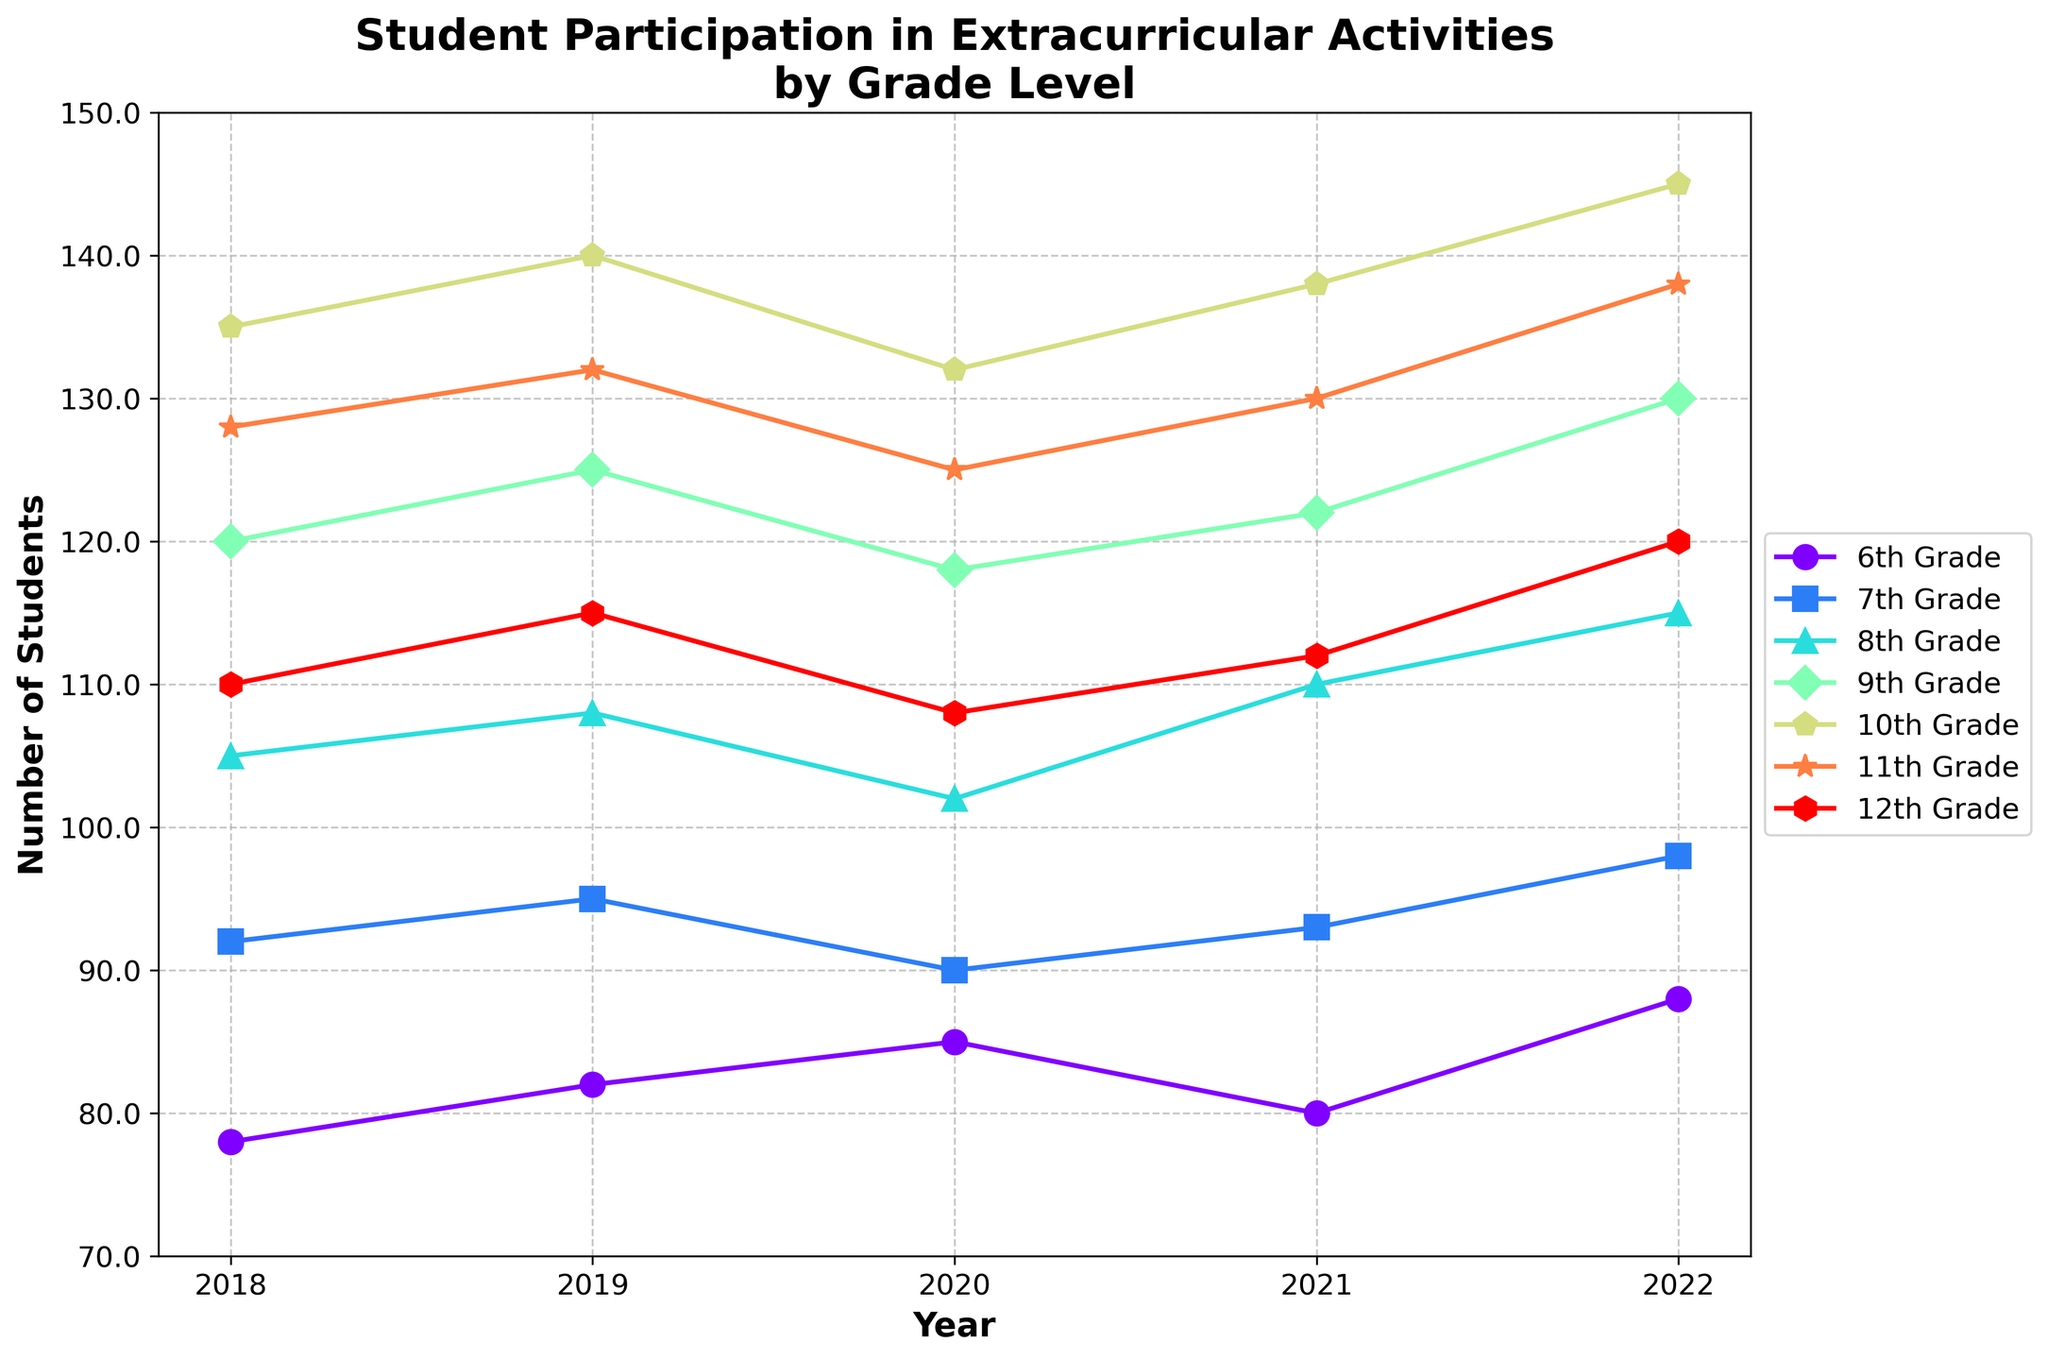What grade level saw the highest number of students participating in extracurricular activities in 2022? To find out which grade level had the highest number of students participating in 2022, look at the highest point on the y-axis corresponding to the year 2022 for all lines. The line for the 10th Grade reaches the highest value.
Answer: 10th Grade Which grade level had the lowest participation in 2018? Check the y-axis values for all grade levels in the year 2018. The 6th Grade has the lowest point on the y-axis in that year.
Answer: 6th Grade What is the average number of students participating in extracurricular activities in the 11th Grade over the given years? Add the participation numbers for the 11th Grade from 2018 to 2022: (128 + 132 + 125 + 130 + 138). Then divide by the number of years, which is 5. The average is (128 + 132 + 125 + 130 + 138) / 5 = 130.6.
Answer: 130.6 Which grades experienced a decrease in participation from 2019 to 2020? Inspect the lines for all grades from the year 2019 to 2020. 7th Grade (95 to 90), 9th Grade (125 to 118), 10th Grade (140 to 132), 11th Grade (132 to 125), and 12th Grade (115 to 108) show a decrease in students.
Answer: 7th, 9th, 10th, 11th, 12th In which year did the 8th Grade have the highest participation and what was the value? For 8th Grade, find the highest point on their line across all years. The highest point is in 2022 with a value of 115.
Answer: 2022, 115 Compare the participation trends between 6th and 7th Grades from 2018 to 2022. Which one showed a more consistent increase? Observe the slope of the lines for both grades from 2018 to 2022. The 6th Grade had values (78, 82, 85, 80, 88), showing small fluctuations with an increase overall. The 7th Grade had values (92, 95, 90, 93, 98), also showing fluctuations. Since both lines show fluctuations but the 6th Grade ends higher relative to its start, it indicates a more consistent increase.
Answer: 6th Grade Calculate the total number of students participating in extracurricular activities in 2020 for all grades combined. Sum up the participation numbers for each grade in 2020: 6th Grade (85), 7th Grade (90), 8th Grade (102), 9th Grade (118), 10th Grade (132), 11th Grade (125), and 12th Grade (108). The total is 85 + 90 + 102 + 118 + 132 + 125 + 108 = 760.
Answer: 760 Which grade had the second highest increase in participation from 2021 to 2022? Calculate the increase for each grade from 2021 to 2022: 6th Grade (88-80 = 8), 7th Grade (98-93 = 5), 8th Grade (115-110 = 5), 9th Grade (130-122 = 8), 10th Grade (145-138 = 7), 11th Grade (138-130 = 8), 12th Grade (120-112 = 8). The second highest increase is for the 10th Grade with 7.
Answer: 10th Grade 